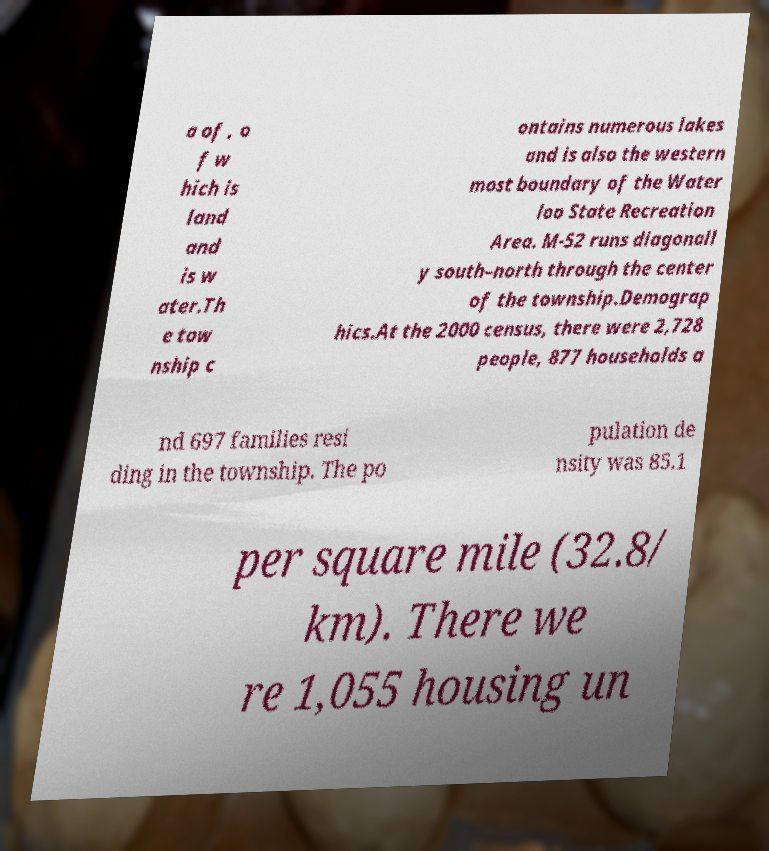Please read and relay the text visible in this image. What does it say? a of , o f w hich is land and is w ater.Th e tow nship c ontains numerous lakes and is also the western most boundary of the Water loo State Recreation Area. M-52 runs diagonall y south–north through the center of the township.Demograp hics.At the 2000 census, there were 2,728 people, 877 households a nd 697 families resi ding in the township. The po pulation de nsity was 85.1 per square mile (32.8/ km). There we re 1,055 housing un 